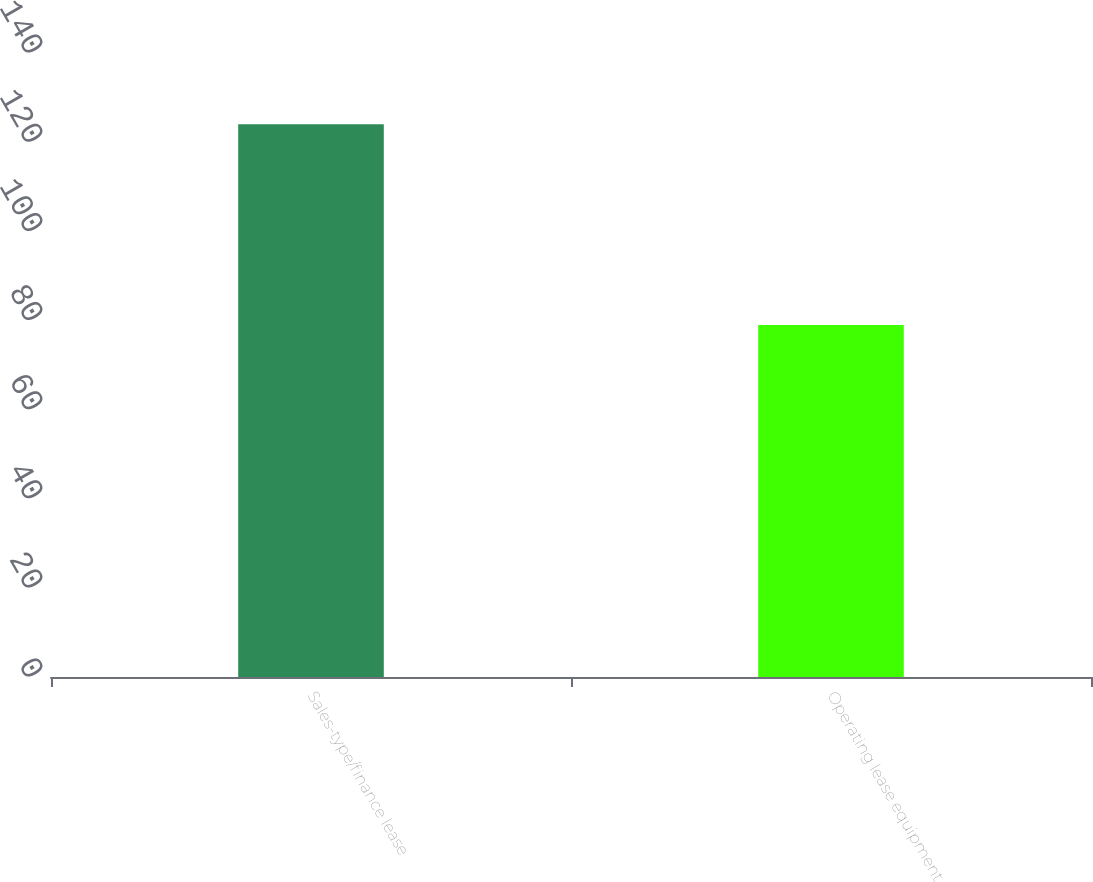Convert chart to OTSL. <chart><loc_0><loc_0><loc_500><loc_500><bar_chart><fcel>Sales-type/finance lease<fcel>Operating lease equipment<nl><fcel>124<fcel>79<nl></chart> 